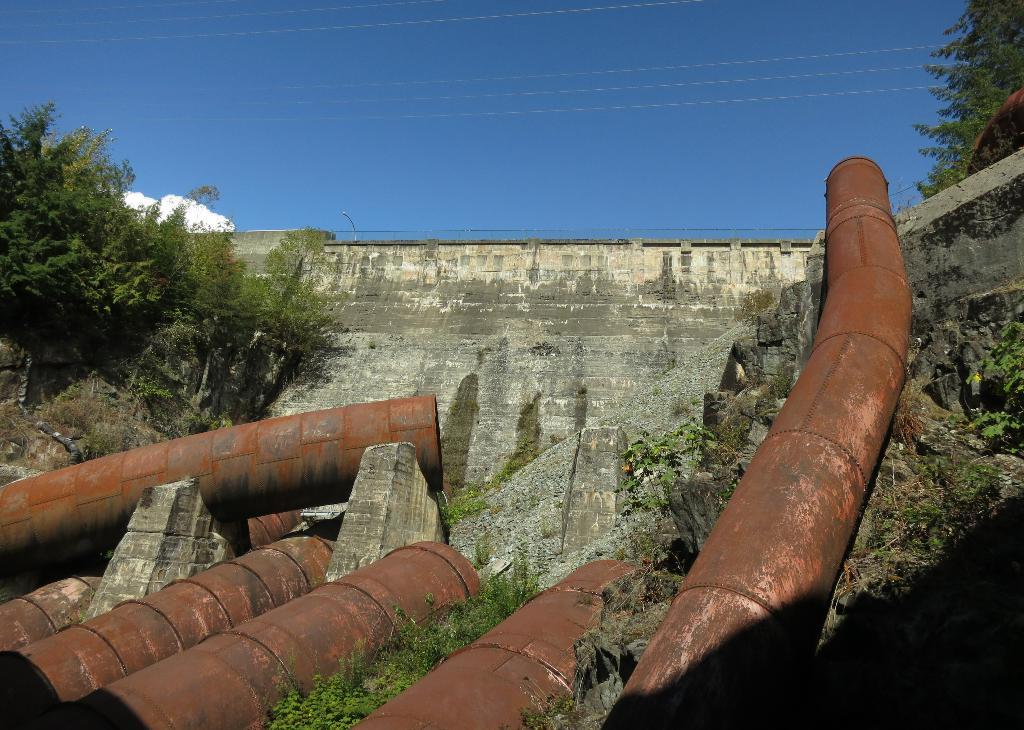What type of material is visible in the image? There are rusted iron pipes in the image. What is located near the pipes? There is a wall beside the pipes. What can be seen on both sides of the pipes? There are trees on either side of the pipes. How does the quilt connect the trees in the image? There is no quilt present in the image, and it does not connect the trees. 